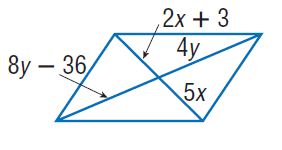Question: Find y so that the quadrilateral is a parallelogram.
Choices:
A. 9
B. 18
C. 36
D. 72
Answer with the letter. Answer: A Question: Find x so that the quadrilateral is a parallelogram.
Choices:
A. 1
B. 2
C. 4
D. 5
Answer with the letter. Answer: A 